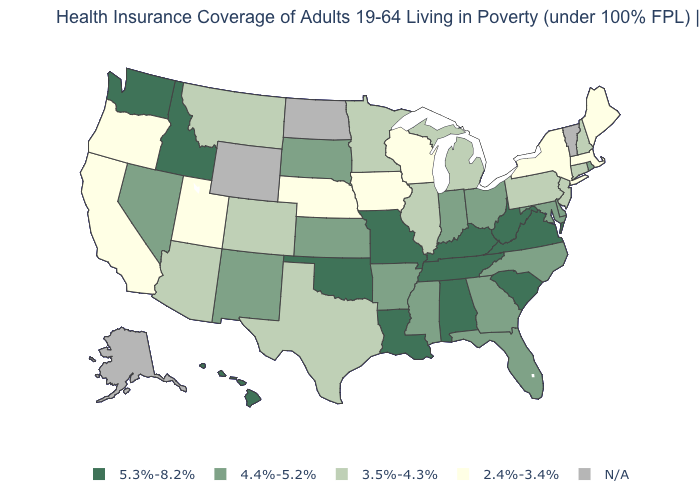What is the value of Alabama?
Concise answer only. 5.3%-8.2%. What is the value of Pennsylvania?
Short answer required. 3.5%-4.3%. What is the value of Michigan?
Quick response, please. 3.5%-4.3%. Does the map have missing data?
Short answer required. Yes. Is the legend a continuous bar?
Quick response, please. No. Which states hav the highest value in the MidWest?
Quick response, please. Missouri. Which states hav the highest value in the MidWest?
Keep it brief. Missouri. What is the highest value in the Northeast ?
Quick response, please. 4.4%-5.2%. Name the states that have a value in the range 4.4%-5.2%?
Keep it brief. Arkansas, Delaware, Florida, Georgia, Indiana, Kansas, Maryland, Mississippi, Nevada, New Mexico, North Carolina, Ohio, Rhode Island, South Dakota. Among the states that border Missouri , does Illinois have the lowest value?
Answer briefly. No. What is the lowest value in the South?
Give a very brief answer. 3.5%-4.3%. Name the states that have a value in the range 5.3%-8.2%?
Answer briefly. Alabama, Hawaii, Idaho, Kentucky, Louisiana, Missouri, Oklahoma, South Carolina, Tennessee, Virginia, Washington, West Virginia. What is the value of Kentucky?
Keep it brief. 5.3%-8.2%. Name the states that have a value in the range 2.4%-3.4%?
Write a very short answer. California, Iowa, Maine, Massachusetts, Nebraska, New York, Oregon, Utah, Wisconsin. 